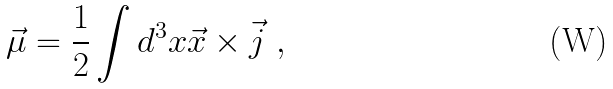<formula> <loc_0><loc_0><loc_500><loc_500>\vec { \mu } = \frac { 1 } { 2 } \int d ^ { 3 } x \vec { x } \times \vec { j } \ ,</formula> 